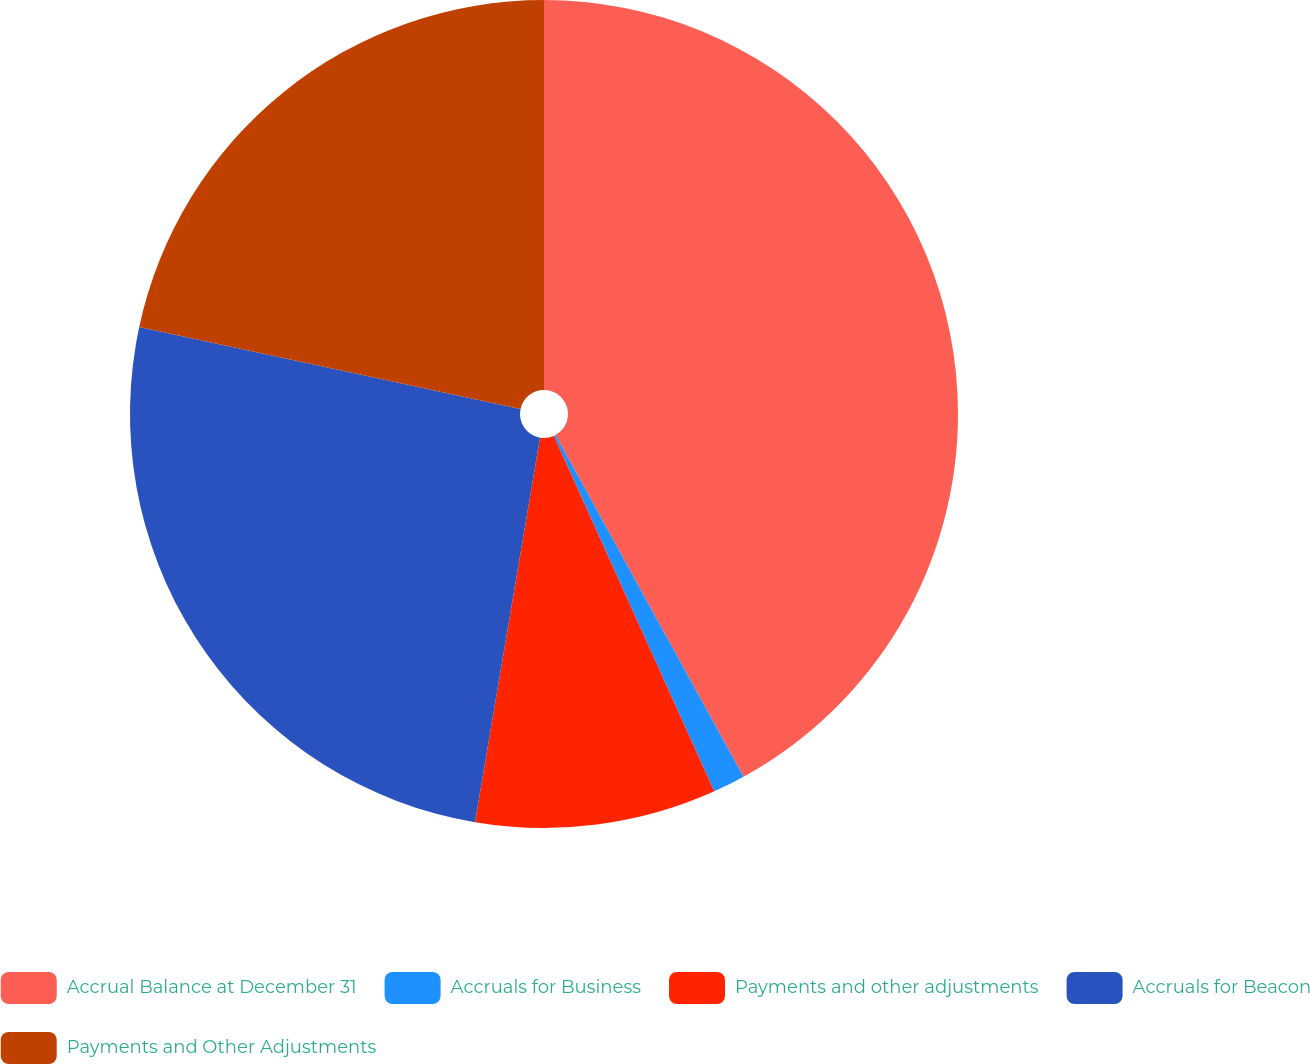Convert chart to OTSL. <chart><loc_0><loc_0><loc_500><loc_500><pie_chart><fcel>Accrual Balance at December 31<fcel>Accruals for Business<fcel>Payments and other adjustments<fcel>Accruals for Beacon<fcel>Payments and Other Adjustments<nl><fcel>41.99%<fcel>1.26%<fcel>9.41%<fcel>25.7%<fcel>21.63%<nl></chart> 